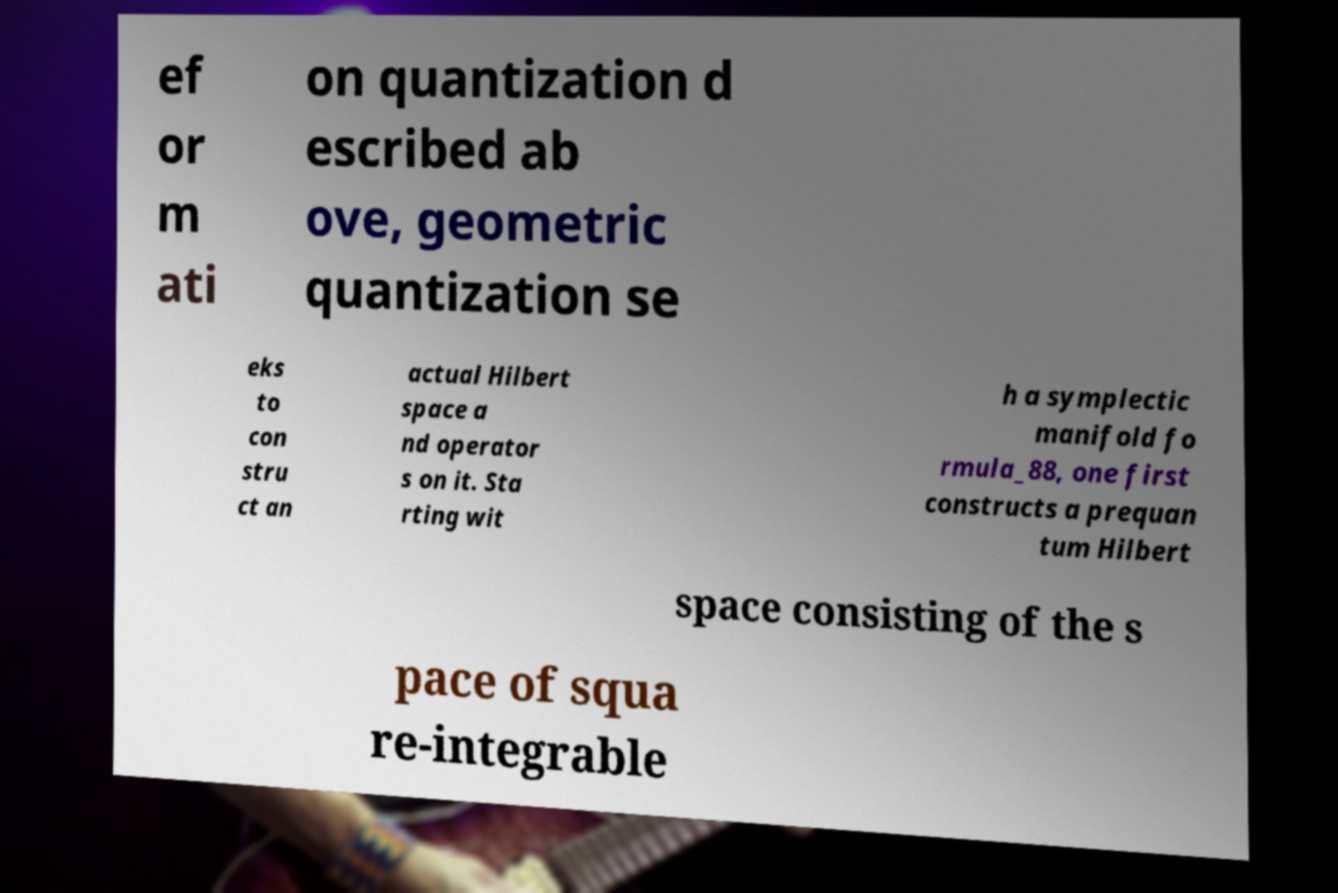I need the written content from this picture converted into text. Can you do that? ef or m ati on quantization d escribed ab ove, geometric quantization se eks to con stru ct an actual Hilbert space a nd operator s on it. Sta rting wit h a symplectic manifold fo rmula_88, one first constructs a prequan tum Hilbert space consisting of the s pace of squa re-integrable 